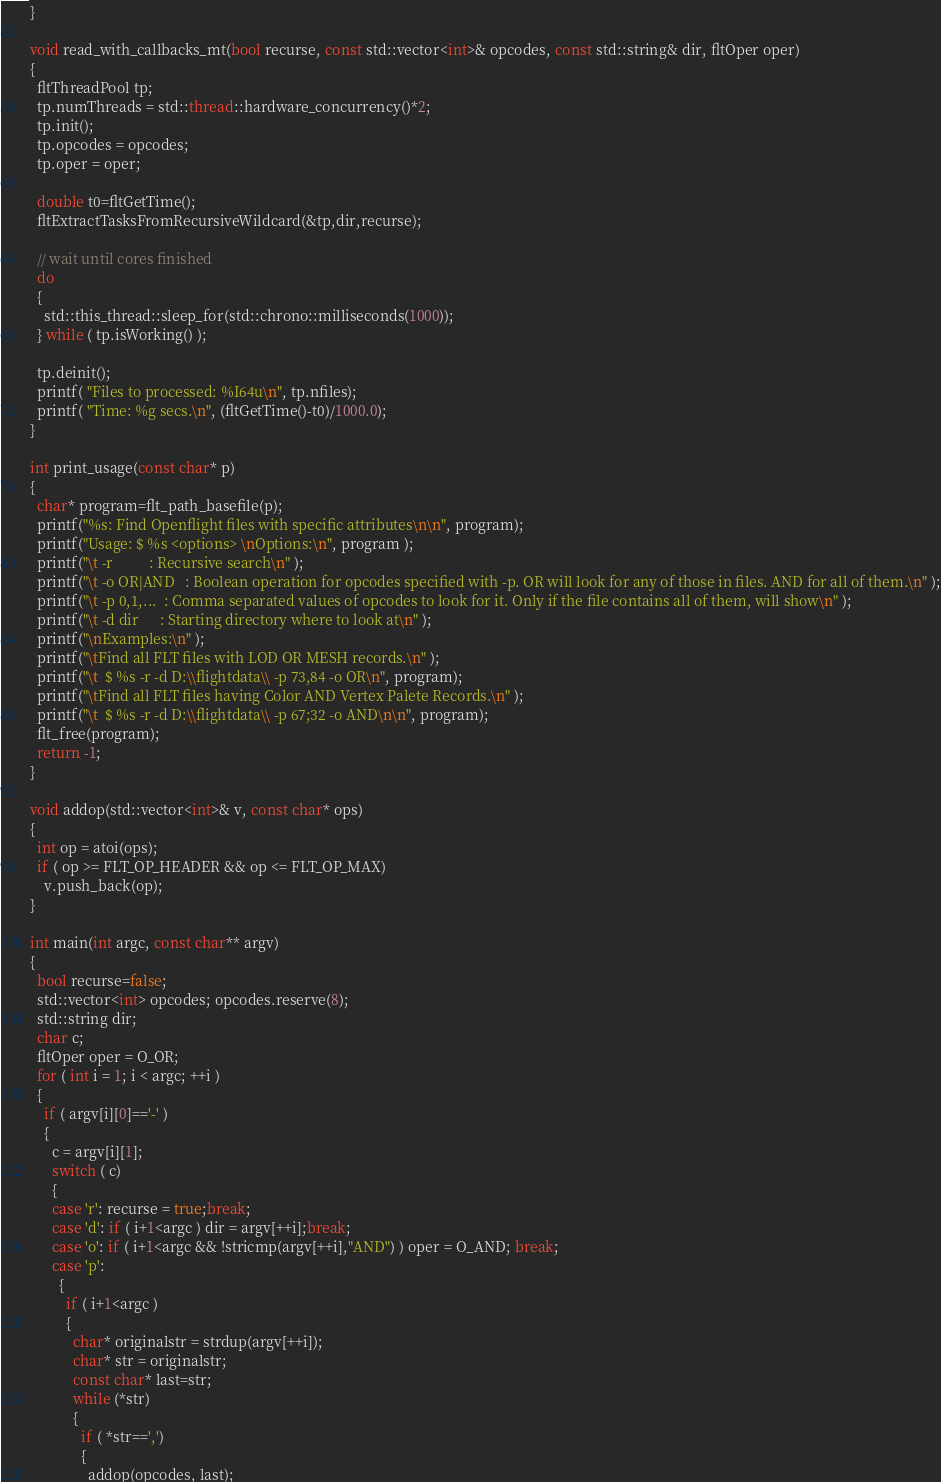Convert code to text. <code><loc_0><loc_0><loc_500><loc_500><_C++_>}

void read_with_callbacks_mt(bool recurse, const std::vector<int>& opcodes, const std::string& dir, fltOper oper)
{
  fltThreadPool tp;
  tp.numThreads = std::thread::hardware_concurrency()*2;
  tp.init();
  tp.opcodes = opcodes;
  tp.oper = oper;

  double t0=fltGetTime();
  fltExtractTasksFromRecursiveWildcard(&tp,dir,recurse);

  // wait until cores finished
  do
  {
    std::this_thread::sleep_for(std::chrono::milliseconds(1000));    
  } while ( tp.isWorking() );

  tp.deinit();
  printf( "Files to processed: %I64u\n", tp.nfiles);
  printf( "Time: %g secs.\n", (fltGetTime()-t0)/1000.0);
}

int print_usage(const char* p)
{
  char* program=flt_path_basefile(p);
  printf("%s: Find Openflight files with specific attributes\n\n", program);
  printf("Usage: $ %s <options> \nOptions:\n", program );    
  printf("\t -r          : Recursive search\n" );
  printf("\t -o OR|AND   : Boolean operation for opcodes specified with -p. OR will look for any of those in files. AND for all of them.\n" );
  printf("\t -p 0,1,...  : Comma separated values of opcodes to look for it. Only if the file contains all of them, will show\n" );
  printf("\t -d dir      : Starting directory where to look at\n" );
  printf("\nExamples:\n" );
  printf("\tFind all FLT files with LOD OR MESH records.\n" );
  printf("\t  $ %s -r -d D:\\flightdata\\ -p 73,84 -o OR\n", program);
  printf("\tFind all FLT files having Color AND Vertex Palete Records.\n" );
  printf("\t  $ %s -r -d D:\\flightdata\\ -p 67;32 -o AND\n\n", program);
  flt_free(program);
  return -1;
}

void addop(std::vector<int>& v, const char* ops)
{
  int op = atoi(ops);
  if ( op >= FLT_OP_HEADER && op <= FLT_OP_MAX)
    v.push_back(op);
}

int main(int argc, const char** argv)
{
  bool recurse=false;
  std::vector<int> opcodes; opcodes.reserve(8);
  std::string dir;
  char c;
  fltOper oper = O_OR;
  for ( int i = 1; i < argc; ++i )
  {
    if ( argv[i][0]=='-' )
    {
      c = argv[i][1];
      switch ( c)
      {
      case 'r': recurse = true;break;
      case 'd': if ( i+1<argc ) dir = argv[++i];break;
      case 'o': if ( i+1<argc && !stricmp(argv[++i],"AND") ) oper = O_AND; break;
      case 'p': 
        {
          if ( i+1<argc )
          {
            char* originalstr = strdup(argv[++i]);
            char* str = originalstr;
            const char* last=str;
            while (*str)
            {
              if ( *str==',')
              {
                addop(opcodes, last);</code> 